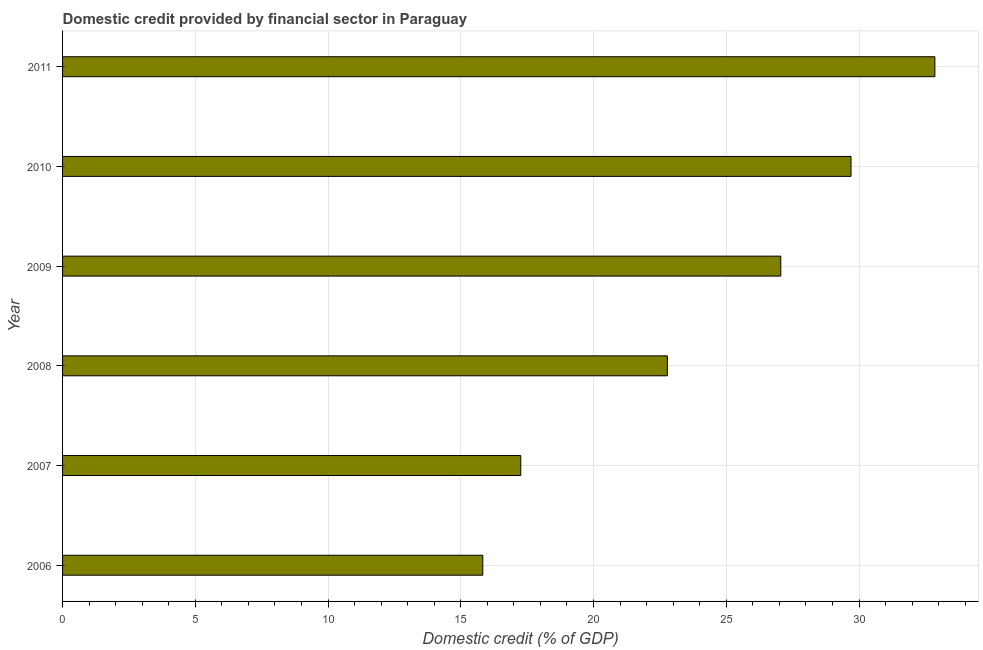Does the graph contain any zero values?
Ensure brevity in your answer.  No. Does the graph contain grids?
Your answer should be very brief. Yes. What is the title of the graph?
Provide a succinct answer. Domestic credit provided by financial sector in Paraguay. What is the label or title of the X-axis?
Give a very brief answer. Domestic credit (% of GDP). What is the domestic credit provided by financial sector in 2007?
Ensure brevity in your answer.  17.26. Across all years, what is the maximum domestic credit provided by financial sector?
Offer a very short reply. 32.86. Across all years, what is the minimum domestic credit provided by financial sector?
Provide a short and direct response. 15.83. In which year was the domestic credit provided by financial sector maximum?
Offer a terse response. 2011. What is the sum of the domestic credit provided by financial sector?
Give a very brief answer. 145.48. What is the difference between the domestic credit provided by financial sector in 2007 and 2011?
Make the answer very short. -15.6. What is the average domestic credit provided by financial sector per year?
Provide a short and direct response. 24.25. What is the median domestic credit provided by financial sector?
Your answer should be compact. 24.92. What is the ratio of the domestic credit provided by financial sector in 2008 to that in 2009?
Ensure brevity in your answer.  0.84. Is the domestic credit provided by financial sector in 2007 less than that in 2009?
Provide a succinct answer. Yes. Is the difference between the domestic credit provided by financial sector in 2006 and 2007 greater than the difference between any two years?
Your response must be concise. No. What is the difference between the highest and the second highest domestic credit provided by financial sector?
Your response must be concise. 3.16. What is the difference between the highest and the lowest domestic credit provided by financial sector?
Make the answer very short. 17.03. In how many years, is the domestic credit provided by financial sector greater than the average domestic credit provided by financial sector taken over all years?
Provide a short and direct response. 3. Are all the bars in the graph horizontal?
Offer a terse response. Yes. How many years are there in the graph?
Make the answer very short. 6. What is the Domestic credit (% of GDP) in 2006?
Offer a very short reply. 15.83. What is the Domestic credit (% of GDP) in 2007?
Offer a very short reply. 17.26. What is the Domestic credit (% of GDP) of 2008?
Keep it short and to the point. 22.78. What is the Domestic credit (% of GDP) of 2009?
Your response must be concise. 27.05. What is the Domestic credit (% of GDP) in 2010?
Keep it short and to the point. 29.7. What is the Domestic credit (% of GDP) in 2011?
Offer a very short reply. 32.86. What is the difference between the Domestic credit (% of GDP) in 2006 and 2007?
Your response must be concise. -1.43. What is the difference between the Domestic credit (% of GDP) in 2006 and 2008?
Your response must be concise. -6.95. What is the difference between the Domestic credit (% of GDP) in 2006 and 2009?
Your response must be concise. -11.22. What is the difference between the Domestic credit (% of GDP) in 2006 and 2010?
Give a very brief answer. -13.87. What is the difference between the Domestic credit (% of GDP) in 2006 and 2011?
Your answer should be compact. -17.03. What is the difference between the Domestic credit (% of GDP) in 2007 and 2008?
Ensure brevity in your answer.  -5.52. What is the difference between the Domestic credit (% of GDP) in 2007 and 2009?
Ensure brevity in your answer.  -9.8. What is the difference between the Domestic credit (% of GDP) in 2007 and 2010?
Offer a terse response. -12.44. What is the difference between the Domestic credit (% of GDP) in 2007 and 2011?
Ensure brevity in your answer.  -15.6. What is the difference between the Domestic credit (% of GDP) in 2008 and 2009?
Your answer should be very brief. -4.27. What is the difference between the Domestic credit (% of GDP) in 2008 and 2010?
Offer a terse response. -6.92. What is the difference between the Domestic credit (% of GDP) in 2008 and 2011?
Your answer should be very brief. -10.08. What is the difference between the Domestic credit (% of GDP) in 2009 and 2010?
Make the answer very short. -2.65. What is the difference between the Domestic credit (% of GDP) in 2009 and 2011?
Your answer should be very brief. -5.8. What is the difference between the Domestic credit (% of GDP) in 2010 and 2011?
Provide a short and direct response. -3.16. What is the ratio of the Domestic credit (% of GDP) in 2006 to that in 2007?
Your answer should be compact. 0.92. What is the ratio of the Domestic credit (% of GDP) in 2006 to that in 2008?
Provide a succinct answer. 0.69. What is the ratio of the Domestic credit (% of GDP) in 2006 to that in 2009?
Your answer should be very brief. 0.58. What is the ratio of the Domestic credit (% of GDP) in 2006 to that in 2010?
Provide a succinct answer. 0.53. What is the ratio of the Domestic credit (% of GDP) in 2006 to that in 2011?
Offer a terse response. 0.48. What is the ratio of the Domestic credit (% of GDP) in 2007 to that in 2008?
Offer a terse response. 0.76. What is the ratio of the Domestic credit (% of GDP) in 2007 to that in 2009?
Offer a terse response. 0.64. What is the ratio of the Domestic credit (% of GDP) in 2007 to that in 2010?
Your response must be concise. 0.58. What is the ratio of the Domestic credit (% of GDP) in 2007 to that in 2011?
Offer a very short reply. 0.53. What is the ratio of the Domestic credit (% of GDP) in 2008 to that in 2009?
Ensure brevity in your answer.  0.84. What is the ratio of the Domestic credit (% of GDP) in 2008 to that in 2010?
Make the answer very short. 0.77. What is the ratio of the Domestic credit (% of GDP) in 2008 to that in 2011?
Give a very brief answer. 0.69. What is the ratio of the Domestic credit (% of GDP) in 2009 to that in 2010?
Make the answer very short. 0.91. What is the ratio of the Domestic credit (% of GDP) in 2009 to that in 2011?
Your answer should be very brief. 0.82. What is the ratio of the Domestic credit (% of GDP) in 2010 to that in 2011?
Offer a terse response. 0.9. 